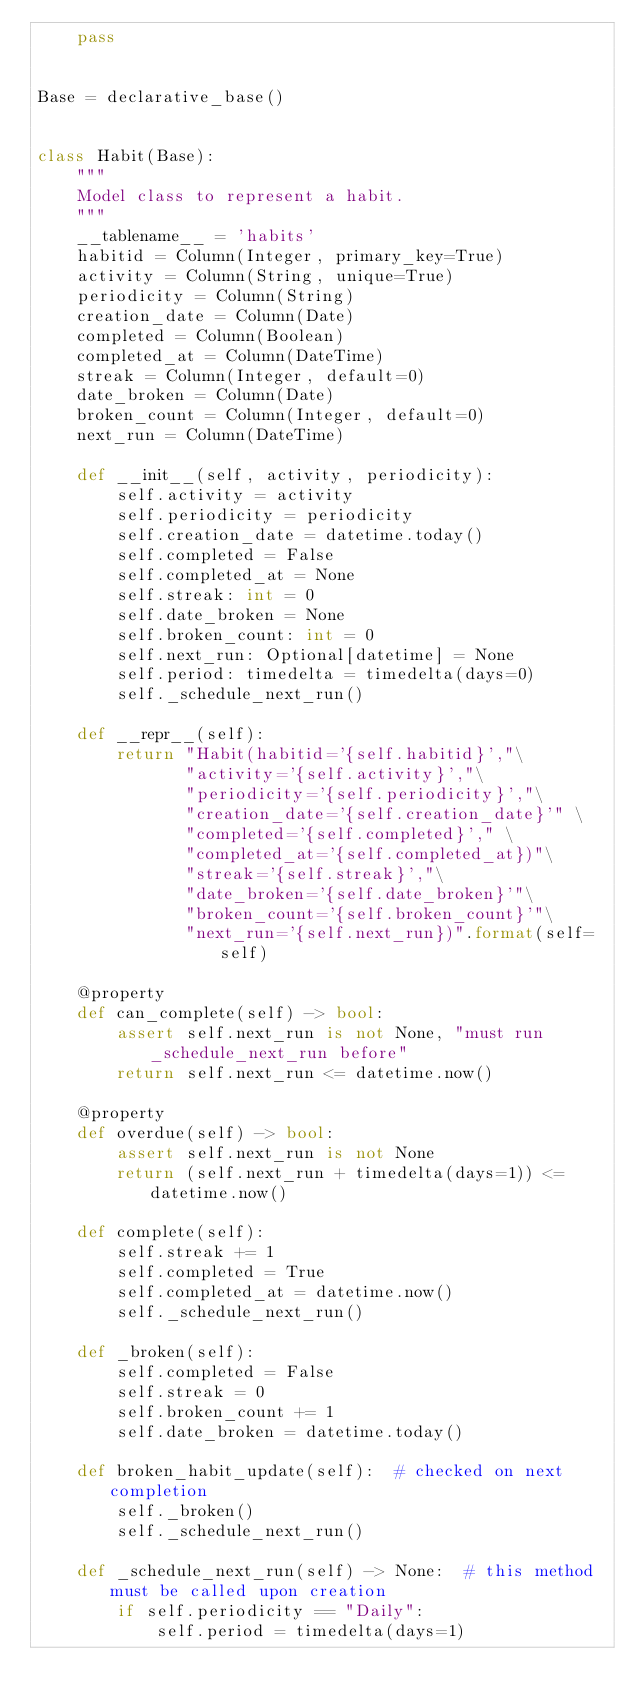<code> <loc_0><loc_0><loc_500><loc_500><_Python_>    pass


Base = declarative_base()


class Habit(Base):
    """
    Model class to represent a habit.
    """
    __tablename__ = 'habits'
    habitid = Column(Integer, primary_key=True)
    activity = Column(String, unique=True)
    periodicity = Column(String)
    creation_date = Column(Date)
    completed = Column(Boolean)
    completed_at = Column(DateTime)
    streak = Column(Integer, default=0)
    date_broken = Column(Date)
    broken_count = Column(Integer, default=0)
    next_run = Column(DateTime)

    def __init__(self, activity, periodicity):
        self.activity = activity
        self.periodicity = periodicity
        self.creation_date = datetime.today()
        self.completed = False
        self.completed_at = None
        self.streak: int = 0
        self.date_broken = None
        self.broken_count: int = 0
        self.next_run: Optional[datetime] = None
        self.period: timedelta = timedelta(days=0)
        self._schedule_next_run()

    def __repr__(self):
        return "Habit(habitid='{self.habitid}',"\
               "activity='{self.activity}',"\
               "periodicity='{self.periodicity}',"\
               "creation_date='{self.creation_date}'" \
               "completed='{self.completed}'," \
               "completed_at='{self.completed_at})"\
               "streak='{self.streak}',"\
               "date_broken='{self.date_broken}'"\
               "broken_count='{self.broken_count}'"\
               "next_run='{self.next_run})".format(self=self)

    @property
    def can_complete(self) -> bool:
        assert self.next_run is not None, "must run _schedule_next_run before"
        return self.next_run <= datetime.now()

    @property
    def overdue(self) -> bool:
        assert self.next_run is not None
        return (self.next_run + timedelta(days=1)) <= datetime.now()

    def complete(self):
        self.streak += 1
        self.completed = True
        self.completed_at = datetime.now()
        self._schedule_next_run()

    def _broken(self):
        self.completed = False
        self.streak = 0
        self.broken_count += 1
        self.date_broken = datetime.today()

    def broken_habit_update(self):  # checked on next completion
        self._broken()
        self._schedule_next_run()

    def _schedule_next_run(self) -> None:  # this method must be called upon creation
        if self.periodicity == "Daily":
            self.period = timedelta(days=1)</code> 